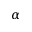Convert formula to latex. <formula><loc_0><loc_0><loc_500><loc_500>\alpha</formula> 